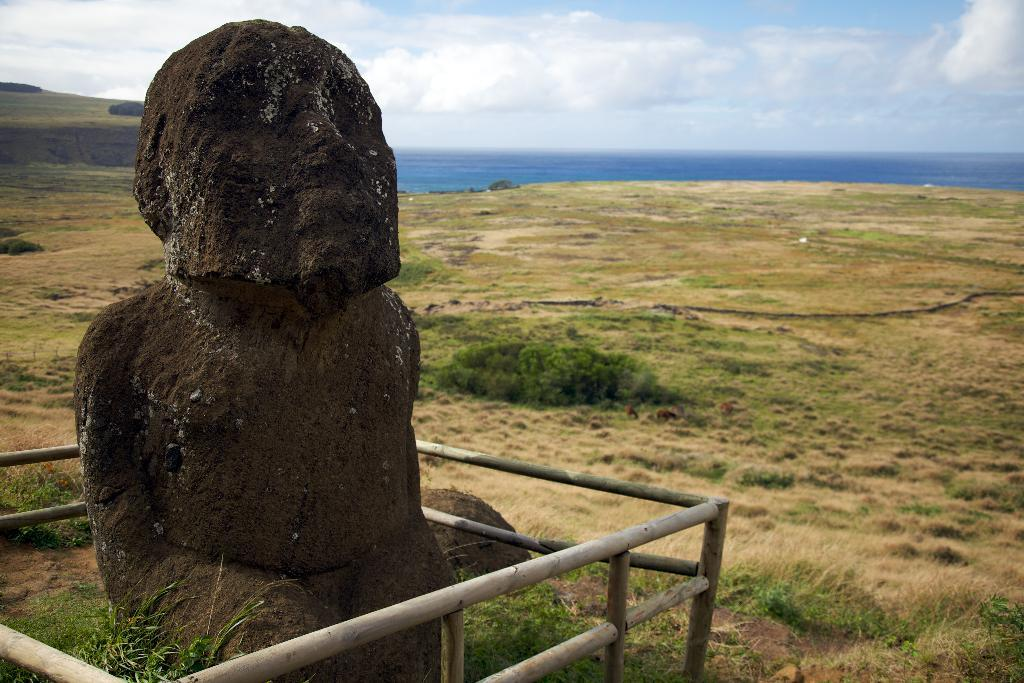What is the main subject in the center of the image? There is a sculpture in the center of the image. What surrounds the sculpture? There is a barrier around the sculpture. What can be seen in the background of the image? The sky, clouds, plants, and grass are visible in the background of the image. How many ladybugs are sitting on the sculpture in the image? There are no ladybugs present in the image; the sculpture and its surroundings are the main focus. 